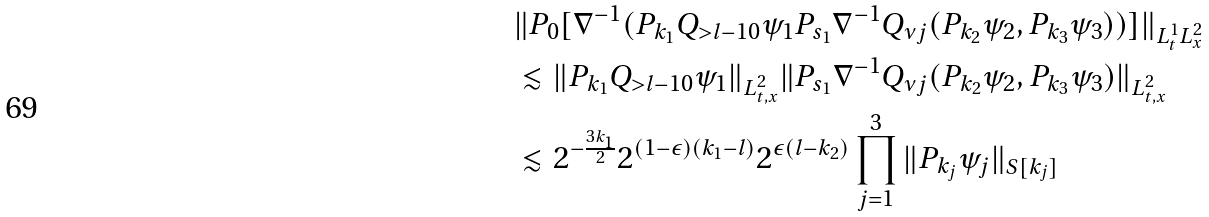Convert formula to latex. <formula><loc_0><loc_0><loc_500><loc_500>& \| P _ { 0 } [ \nabla ^ { - 1 } ( P _ { k _ { 1 } } Q _ { > l - 1 0 } \psi _ { 1 } P _ { s _ { 1 } } \nabla ^ { - 1 } Q _ { \nu j } ( P _ { k _ { 2 } } \psi _ { 2 } , P _ { k _ { 3 } } \psi _ { 3 } ) ) ] \| _ { L _ { t } ^ { 1 } L _ { x } ^ { 2 } } \\ & \lesssim \| P _ { k _ { 1 } } Q _ { > l - 1 0 } \psi _ { 1 } \| _ { L _ { t , x } ^ { 2 } } \| P _ { s _ { 1 } } \nabla ^ { - 1 } Q _ { \nu j } ( P _ { k _ { 2 } } \psi _ { 2 } , P _ { k _ { 3 } } \psi _ { 3 } ) \| _ { L _ { t , x } ^ { 2 } } \\ & \lesssim 2 ^ { - \frac { 3 k _ { 1 } } { 2 } } 2 ^ { ( 1 - \epsilon ) ( k _ { 1 } - l ) } 2 ^ { \epsilon ( l - k _ { 2 } ) } \prod _ { j = 1 } ^ { 3 } \| P _ { k _ { j } } \psi _ { j } \| _ { S [ k _ { j } ] }</formula> 